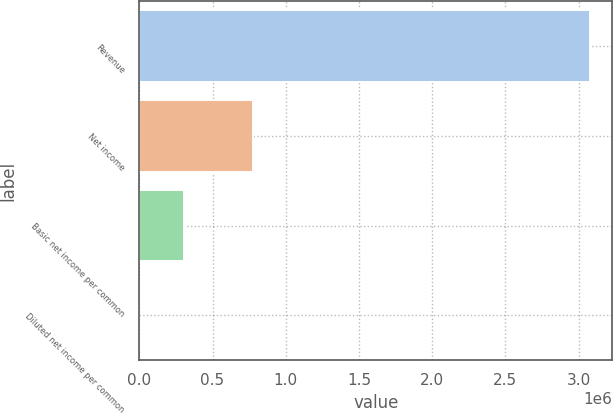Convert chart to OTSL. <chart><loc_0><loc_0><loc_500><loc_500><bar_chart><fcel>Revenue<fcel>Net income<fcel>Basic net income per common<fcel>Diluted net income per common<nl><fcel>3.07547e+06<fcel>778049<fcel>307549<fcel>2.44<nl></chart> 